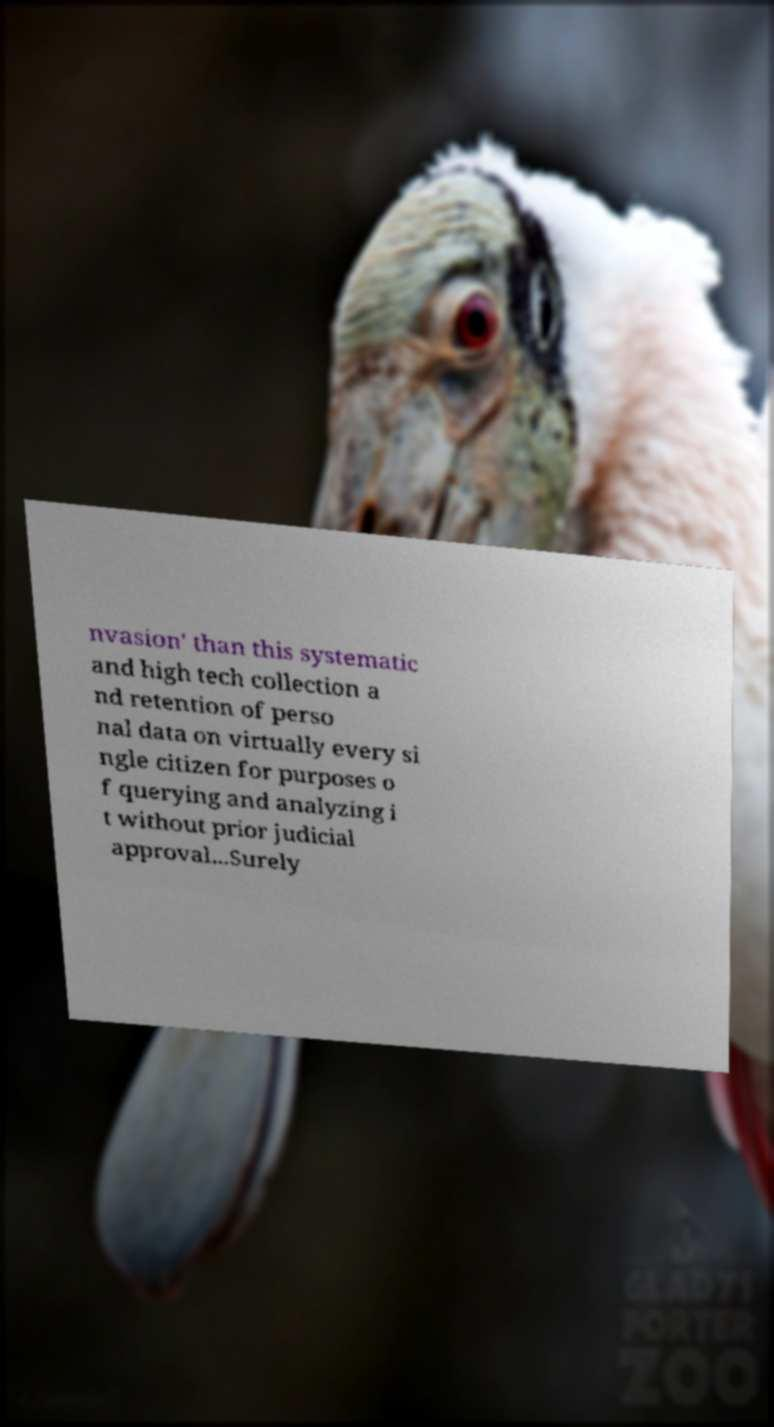Could you extract and type out the text from this image? nvasion' than this systematic and high tech collection a nd retention of perso nal data on virtually every si ngle citizen for purposes o f querying and analyzing i t without prior judicial approval...Surely 